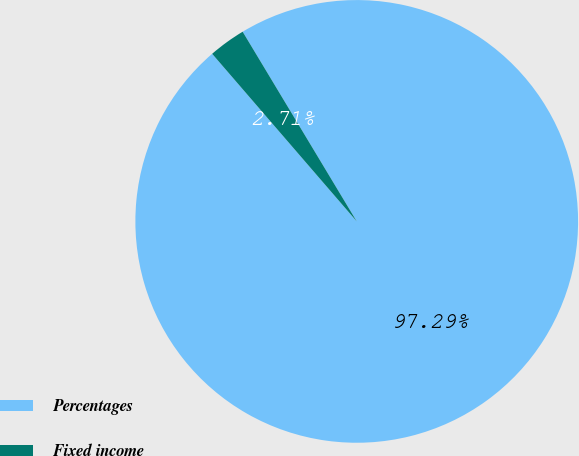Convert chart to OTSL. <chart><loc_0><loc_0><loc_500><loc_500><pie_chart><fcel>Percentages<fcel>Fixed income<nl><fcel>97.29%<fcel>2.71%<nl></chart> 